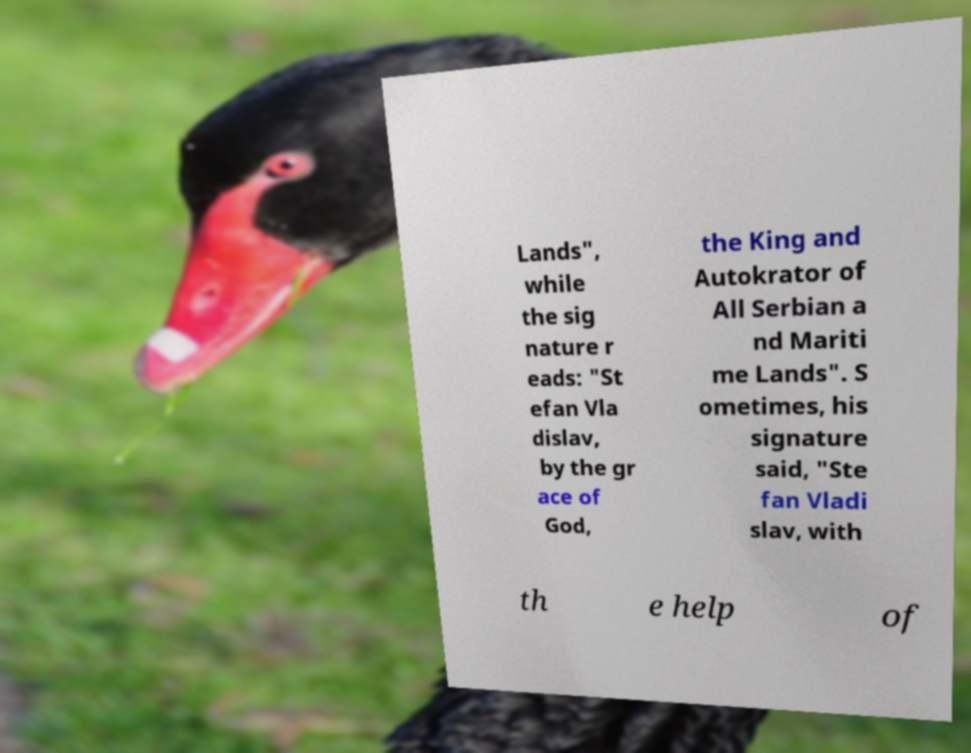Could you extract and type out the text from this image? Lands", while the sig nature r eads: "St efan Vla dislav, by the gr ace of God, the King and Autokrator of All Serbian a nd Mariti me Lands". S ometimes, his signature said, "Ste fan Vladi slav, with th e help of 